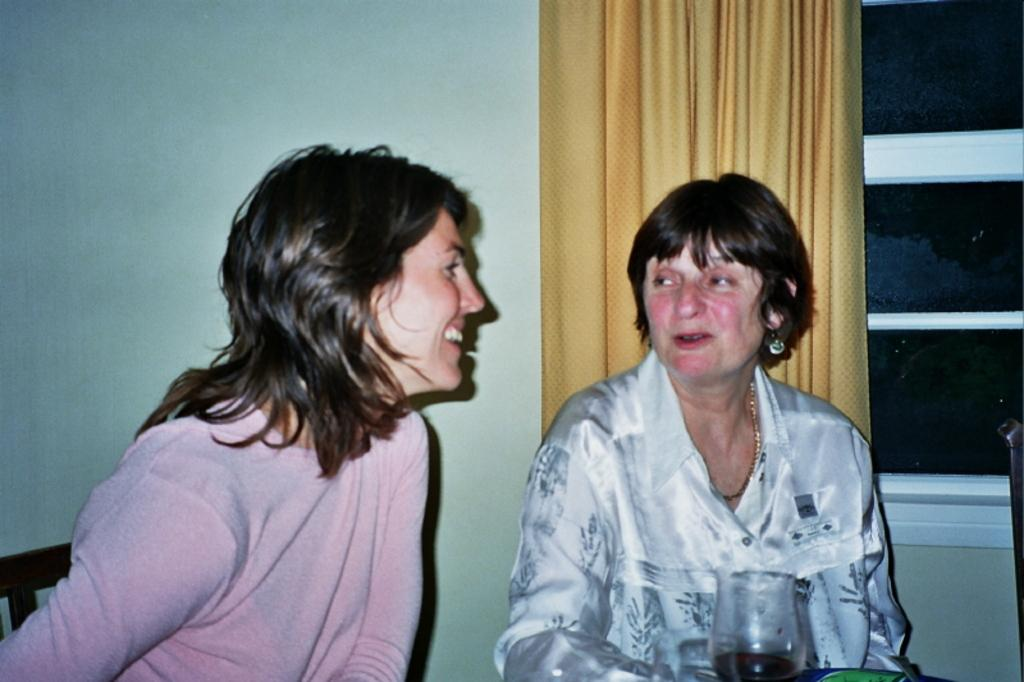What is located in the foreground of the image? There are women and a glass in the foreground of the image. Can you describe the background of the image? There is a window and a curtain associated with the window in the background of the image. What type of beef is being served at the boundary in the image? There is no beef or boundary present in the image. 